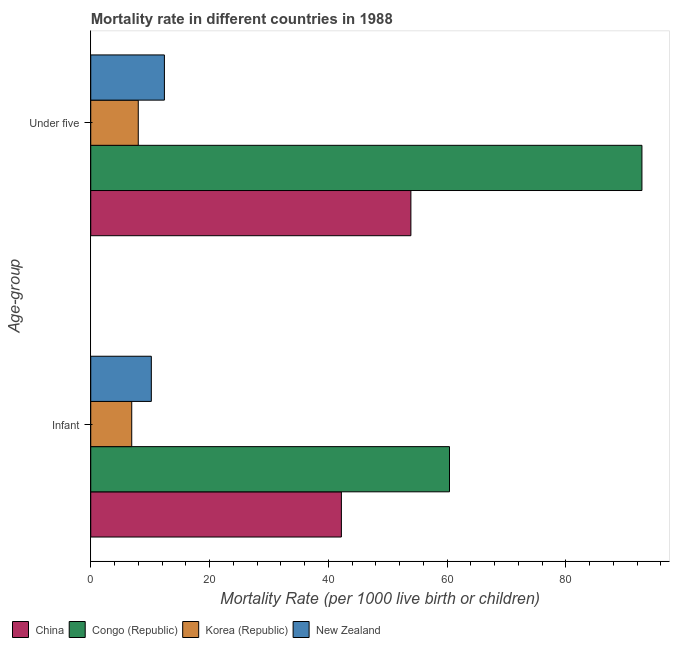How many different coloured bars are there?
Offer a very short reply. 4. What is the label of the 2nd group of bars from the top?
Provide a succinct answer. Infant. Across all countries, what is the maximum infant mortality rate?
Offer a very short reply. 60.4. In which country was the under-5 mortality rate maximum?
Make the answer very short. Congo (Republic). In which country was the under-5 mortality rate minimum?
Make the answer very short. Korea (Republic). What is the total under-5 mortality rate in the graph?
Ensure brevity in your answer.  167.1. What is the difference between the under-5 mortality rate in New Zealand and that in Korea (Republic)?
Offer a terse response. 4.4. What is the difference between the infant mortality rate in New Zealand and the under-5 mortality rate in Congo (Republic)?
Provide a short and direct response. -82.6. What is the average infant mortality rate per country?
Offer a very short reply. 29.93. What is the difference between the infant mortality rate and under-5 mortality rate in New Zealand?
Keep it short and to the point. -2.2. What is the ratio of the infant mortality rate in Korea (Republic) to that in Congo (Republic)?
Keep it short and to the point. 0.11. In how many countries, is the under-5 mortality rate greater than the average under-5 mortality rate taken over all countries?
Your answer should be very brief. 2. What does the 1st bar from the top in Under five represents?
Offer a very short reply. New Zealand. How many bars are there?
Your answer should be compact. 8. Are all the bars in the graph horizontal?
Your answer should be very brief. Yes. Are the values on the major ticks of X-axis written in scientific E-notation?
Make the answer very short. No. Does the graph contain grids?
Give a very brief answer. No. How many legend labels are there?
Provide a short and direct response. 4. What is the title of the graph?
Make the answer very short. Mortality rate in different countries in 1988. Does "Low & middle income" appear as one of the legend labels in the graph?
Ensure brevity in your answer.  No. What is the label or title of the X-axis?
Your response must be concise. Mortality Rate (per 1000 live birth or children). What is the label or title of the Y-axis?
Make the answer very short. Age-group. What is the Mortality Rate (per 1000 live birth or children) of China in Infant?
Your response must be concise. 42.2. What is the Mortality Rate (per 1000 live birth or children) of Congo (Republic) in Infant?
Provide a succinct answer. 60.4. What is the Mortality Rate (per 1000 live birth or children) in China in Under five?
Provide a succinct answer. 53.9. What is the Mortality Rate (per 1000 live birth or children) of Congo (Republic) in Under five?
Give a very brief answer. 92.8. What is the Mortality Rate (per 1000 live birth or children) of Korea (Republic) in Under five?
Offer a terse response. 8. Across all Age-group, what is the maximum Mortality Rate (per 1000 live birth or children) in China?
Provide a short and direct response. 53.9. Across all Age-group, what is the maximum Mortality Rate (per 1000 live birth or children) in Congo (Republic)?
Provide a succinct answer. 92.8. Across all Age-group, what is the maximum Mortality Rate (per 1000 live birth or children) of Korea (Republic)?
Give a very brief answer. 8. Across all Age-group, what is the minimum Mortality Rate (per 1000 live birth or children) in China?
Your answer should be very brief. 42.2. Across all Age-group, what is the minimum Mortality Rate (per 1000 live birth or children) in Congo (Republic)?
Ensure brevity in your answer.  60.4. Across all Age-group, what is the minimum Mortality Rate (per 1000 live birth or children) of Korea (Republic)?
Provide a short and direct response. 6.9. What is the total Mortality Rate (per 1000 live birth or children) of China in the graph?
Offer a very short reply. 96.1. What is the total Mortality Rate (per 1000 live birth or children) of Congo (Republic) in the graph?
Provide a short and direct response. 153.2. What is the total Mortality Rate (per 1000 live birth or children) of Korea (Republic) in the graph?
Your answer should be very brief. 14.9. What is the total Mortality Rate (per 1000 live birth or children) in New Zealand in the graph?
Keep it short and to the point. 22.6. What is the difference between the Mortality Rate (per 1000 live birth or children) in Congo (Republic) in Infant and that in Under five?
Your answer should be compact. -32.4. What is the difference between the Mortality Rate (per 1000 live birth or children) of Korea (Republic) in Infant and that in Under five?
Offer a terse response. -1.1. What is the difference between the Mortality Rate (per 1000 live birth or children) of China in Infant and the Mortality Rate (per 1000 live birth or children) of Congo (Republic) in Under five?
Make the answer very short. -50.6. What is the difference between the Mortality Rate (per 1000 live birth or children) in China in Infant and the Mortality Rate (per 1000 live birth or children) in Korea (Republic) in Under five?
Provide a short and direct response. 34.2. What is the difference between the Mortality Rate (per 1000 live birth or children) of China in Infant and the Mortality Rate (per 1000 live birth or children) of New Zealand in Under five?
Ensure brevity in your answer.  29.8. What is the difference between the Mortality Rate (per 1000 live birth or children) of Congo (Republic) in Infant and the Mortality Rate (per 1000 live birth or children) of Korea (Republic) in Under five?
Provide a succinct answer. 52.4. What is the difference between the Mortality Rate (per 1000 live birth or children) in Korea (Republic) in Infant and the Mortality Rate (per 1000 live birth or children) in New Zealand in Under five?
Give a very brief answer. -5.5. What is the average Mortality Rate (per 1000 live birth or children) in China per Age-group?
Your answer should be compact. 48.05. What is the average Mortality Rate (per 1000 live birth or children) in Congo (Republic) per Age-group?
Ensure brevity in your answer.  76.6. What is the average Mortality Rate (per 1000 live birth or children) of Korea (Republic) per Age-group?
Your response must be concise. 7.45. What is the average Mortality Rate (per 1000 live birth or children) in New Zealand per Age-group?
Keep it short and to the point. 11.3. What is the difference between the Mortality Rate (per 1000 live birth or children) of China and Mortality Rate (per 1000 live birth or children) of Congo (Republic) in Infant?
Ensure brevity in your answer.  -18.2. What is the difference between the Mortality Rate (per 1000 live birth or children) of China and Mortality Rate (per 1000 live birth or children) of Korea (Republic) in Infant?
Keep it short and to the point. 35.3. What is the difference between the Mortality Rate (per 1000 live birth or children) in Congo (Republic) and Mortality Rate (per 1000 live birth or children) in Korea (Republic) in Infant?
Ensure brevity in your answer.  53.5. What is the difference between the Mortality Rate (per 1000 live birth or children) of Congo (Republic) and Mortality Rate (per 1000 live birth or children) of New Zealand in Infant?
Provide a short and direct response. 50.2. What is the difference between the Mortality Rate (per 1000 live birth or children) of Korea (Republic) and Mortality Rate (per 1000 live birth or children) of New Zealand in Infant?
Provide a short and direct response. -3.3. What is the difference between the Mortality Rate (per 1000 live birth or children) in China and Mortality Rate (per 1000 live birth or children) in Congo (Republic) in Under five?
Make the answer very short. -38.9. What is the difference between the Mortality Rate (per 1000 live birth or children) in China and Mortality Rate (per 1000 live birth or children) in Korea (Republic) in Under five?
Make the answer very short. 45.9. What is the difference between the Mortality Rate (per 1000 live birth or children) in China and Mortality Rate (per 1000 live birth or children) in New Zealand in Under five?
Offer a very short reply. 41.5. What is the difference between the Mortality Rate (per 1000 live birth or children) in Congo (Republic) and Mortality Rate (per 1000 live birth or children) in Korea (Republic) in Under five?
Offer a very short reply. 84.8. What is the difference between the Mortality Rate (per 1000 live birth or children) of Congo (Republic) and Mortality Rate (per 1000 live birth or children) of New Zealand in Under five?
Your response must be concise. 80.4. What is the difference between the Mortality Rate (per 1000 live birth or children) in Korea (Republic) and Mortality Rate (per 1000 live birth or children) in New Zealand in Under five?
Your answer should be compact. -4.4. What is the ratio of the Mortality Rate (per 1000 live birth or children) in China in Infant to that in Under five?
Offer a very short reply. 0.78. What is the ratio of the Mortality Rate (per 1000 live birth or children) in Congo (Republic) in Infant to that in Under five?
Give a very brief answer. 0.65. What is the ratio of the Mortality Rate (per 1000 live birth or children) of Korea (Republic) in Infant to that in Under five?
Make the answer very short. 0.86. What is the ratio of the Mortality Rate (per 1000 live birth or children) in New Zealand in Infant to that in Under five?
Offer a terse response. 0.82. What is the difference between the highest and the second highest Mortality Rate (per 1000 live birth or children) of China?
Provide a succinct answer. 11.7. What is the difference between the highest and the second highest Mortality Rate (per 1000 live birth or children) of Congo (Republic)?
Offer a terse response. 32.4. What is the difference between the highest and the second highest Mortality Rate (per 1000 live birth or children) in Korea (Republic)?
Your answer should be very brief. 1.1. What is the difference between the highest and the lowest Mortality Rate (per 1000 live birth or children) of Congo (Republic)?
Keep it short and to the point. 32.4. What is the difference between the highest and the lowest Mortality Rate (per 1000 live birth or children) in Korea (Republic)?
Provide a short and direct response. 1.1. 